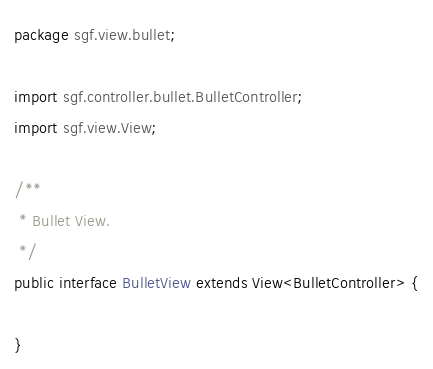<code> <loc_0><loc_0><loc_500><loc_500><_Java_>package sgf.view.bullet;

import sgf.controller.bullet.BulletController;
import sgf.view.View;

/**
 * Bullet View.
 */
public interface BulletView extends View<BulletController> {

}
</code> 